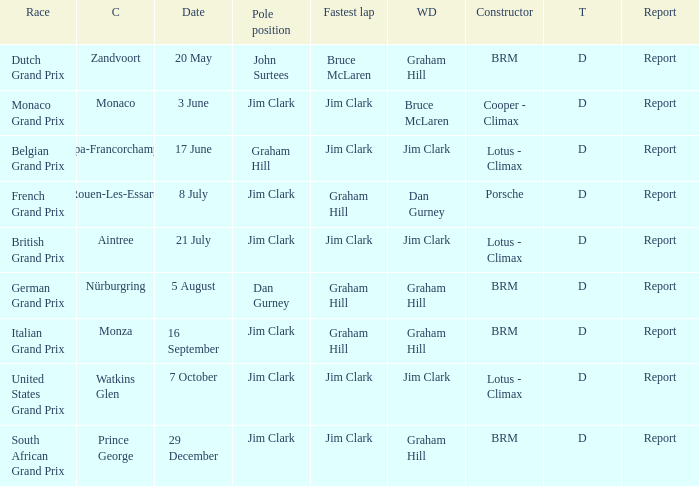What is the date of the circuit of nürburgring, which had Graham Hill as the winning driver? 5 August. 